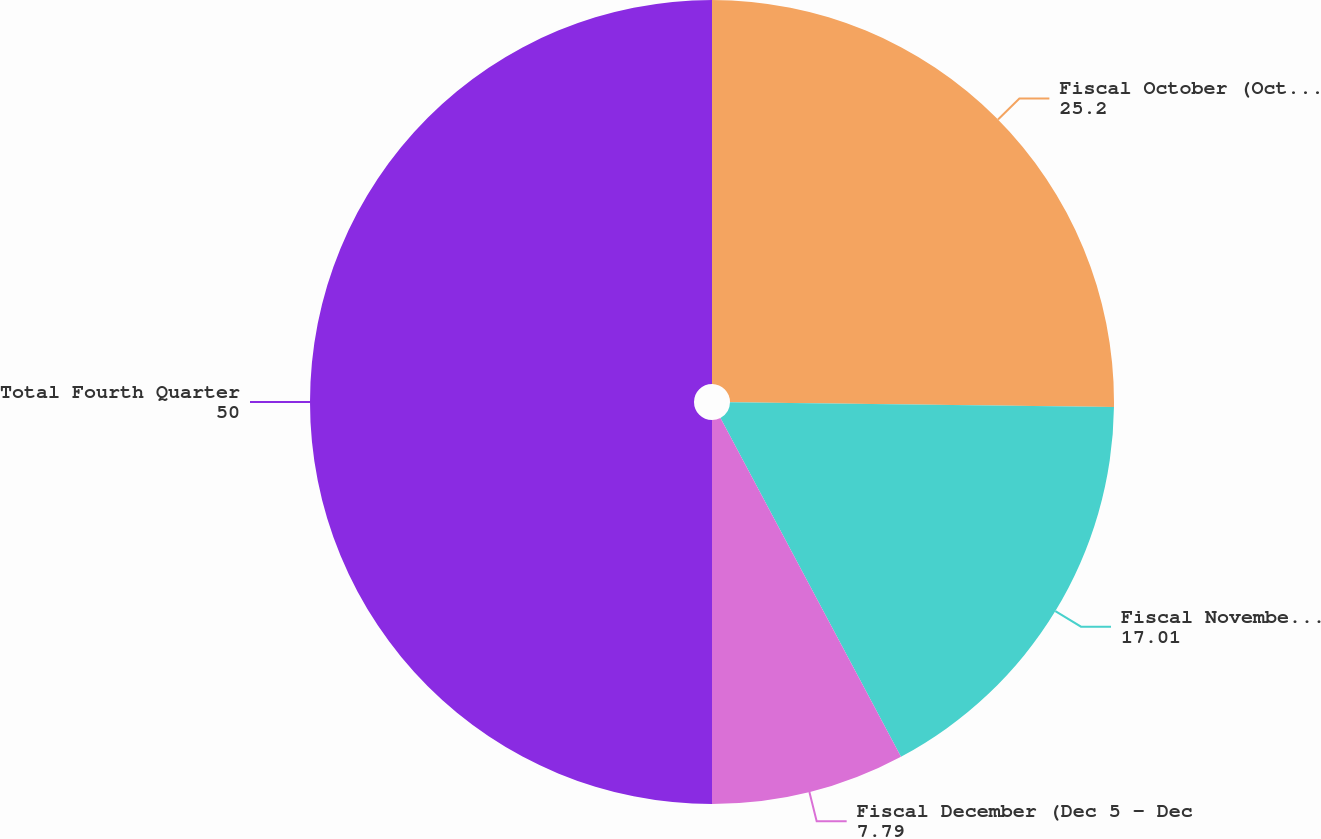<chart> <loc_0><loc_0><loc_500><loc_500><pie_chart><fcel>Fiscal October (Oct 3 - Nov 6)<fcel>Fiscal November (Nov 7 - Dec<fcel>Fiscal December (Dec 5 - Dec<fcel>Total Fourth Quarter<nl><fcel>25.2%<fcel>17.01%<fcel>7.79%<fcel>50.0%<nl></chart> 